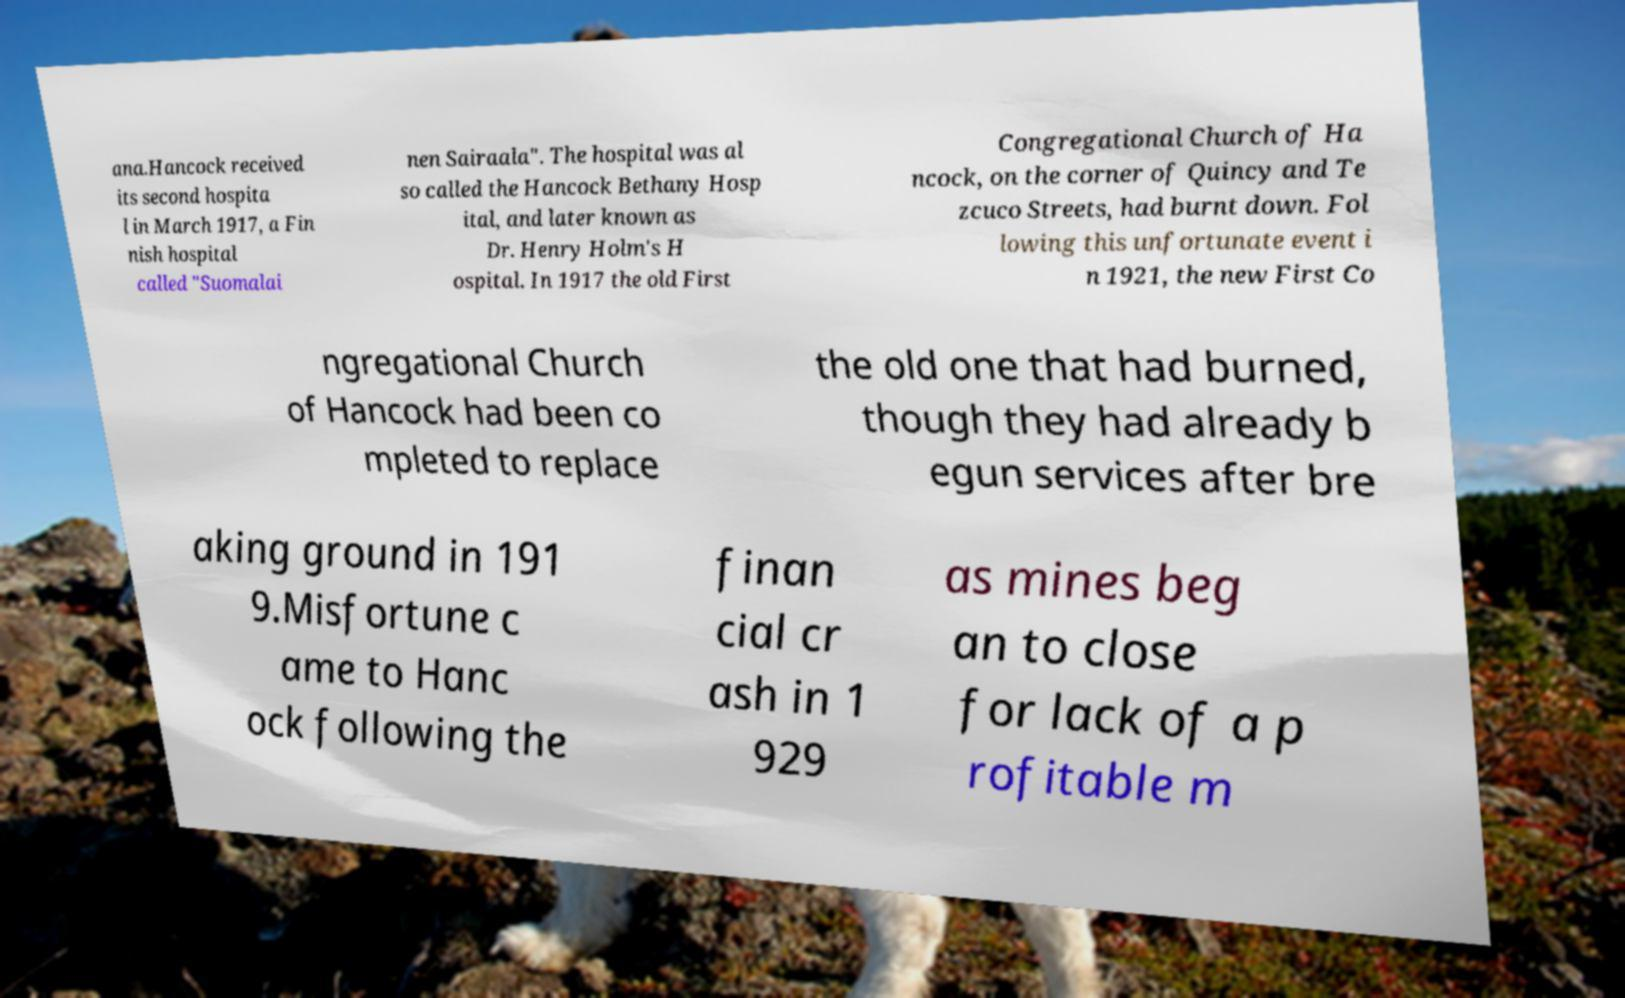Please read and relay the text visible in this image. What does it say? ana.Hancock received its second hospita l in March 1917, a Fin nish hospital called "Suomalai nen Sairaala". The hospital was al so called the Hancock Bethany Hosp ital, and later known as Dr. Henry Holm's H ospital. In 1917 the old First Congregational Church of Ha ncock, on the corner of Quincy and Te zcuco Streets, had burnt down. Fol lowing this unfortunate event i n 1921, the new First Co ngregational Church of Hancock had been co mpleted to replace the old one that had burned, though they had already b egun services after bre aking ground in 191 9.Misfortune c ame to Hanc ock following the finan cial cr ash in 1 929 as mines beg an to close for lack of a p rofitable m 